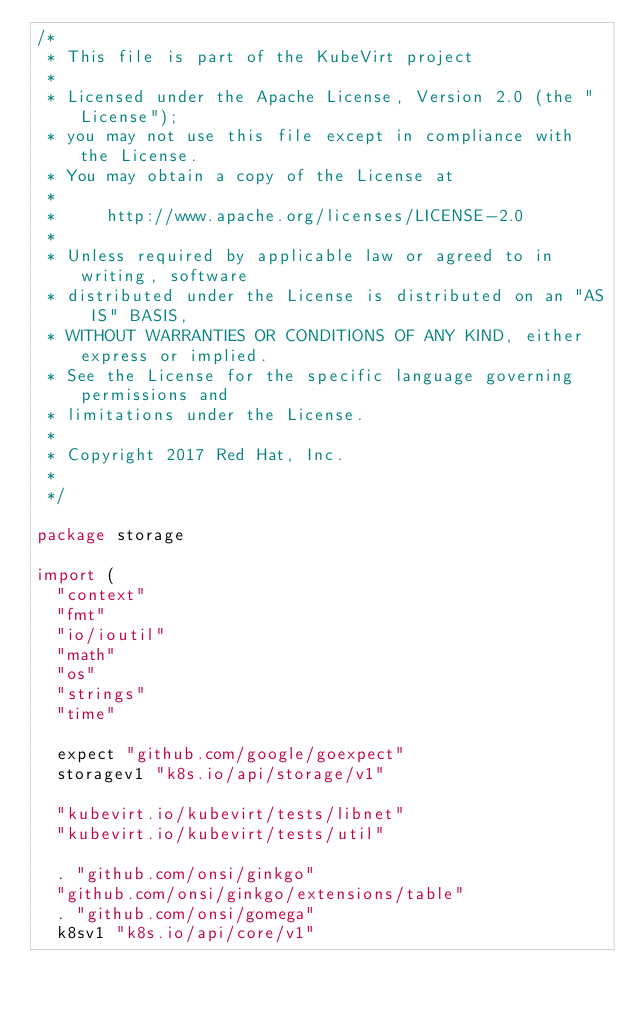<code> <loc_0><loc_0><loc_500><loc_500><_Go_>/*
 * This file is part of the KubeVirt project
 *
 * Licensed under the Apache License, Version 2.0 (the "License");
 * you may not use this file except in compliance with the License.
 * You may obtain a copy of the License at
 *
 *     http://www.apache.org/licenses/LICENSE-2.0
 *
 * Unless required by applicable law or agreed to in writing, software
 * distributed under the License is distributed on an "AS IS" BASIS,
 * WITHOUT WARRANTIES OR CONDITIONS OF ANY KIND, either express or implied.
 * See the License for the specific language governing permissions and
 * limitations under the License.
 *
 * Copyright 2017 Red Hat, Inc.
 *
 */

package storage

import (
	"context"
	"fmt"
	"io/ioutil"
	"math"
	"os"
	"strings"
	"time"

	expect "github.com/google/goexpect"
	storagev1 "k8s.io/api/storage/v1"

	"kubevirt.io/kubevirt/tests/libnet"
	"kubevirt.io/kubevirt/tests/util"

	. "github.com/onsi/ginkgo"
	"github.com/onsi/ginkgo/extensions/table"
	. "github.com/onsi/gomega"
	k8sv1 "k8s.io/api/core/v1"</code> 